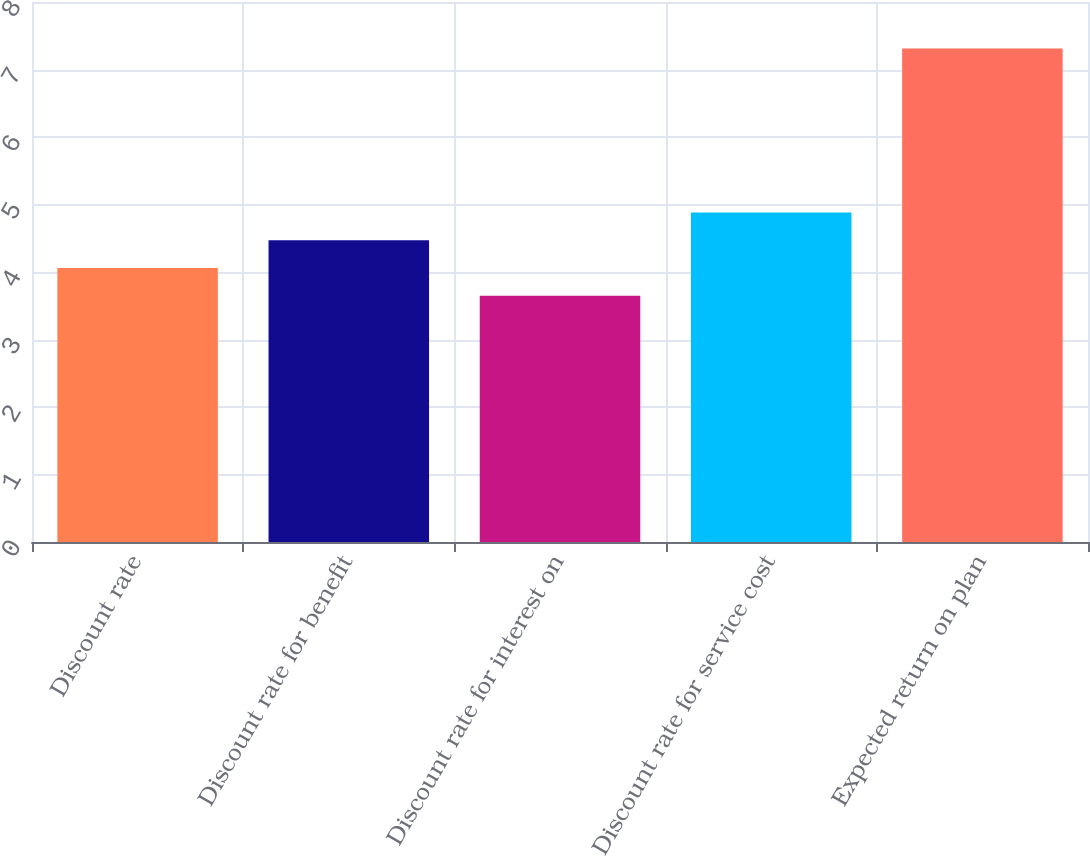Convert chart. <chart><loc_0><loc_0><loc_500><loc_500><bar_chart><fcel>Discount rate<fcel>Discount rate for benefit<fcel>Discount rate for interest on<fcel>Discount rate for service cost<fcel>Expected return on plan<nl><fcel>4.06<fcel>4.47<fcel>3.65<fcel>4.88<fcel>7.31<nl></chart> 